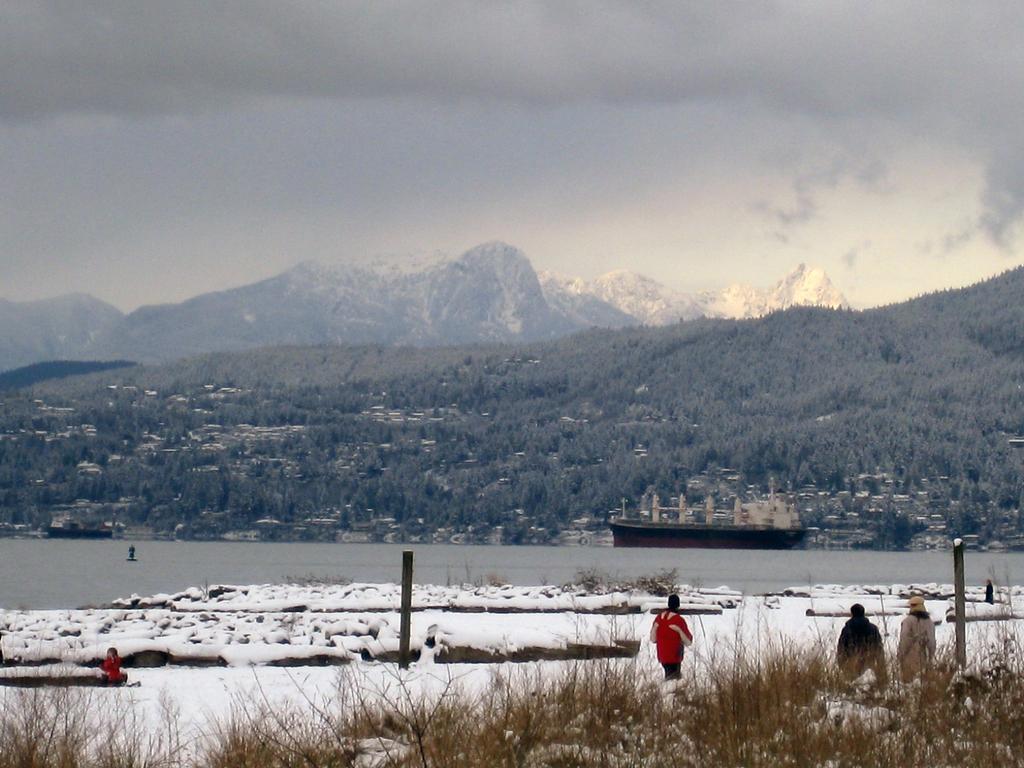Can you describe this image briefly? In this image we can see few people and there is snow on the ground and we can see the lake. There is a ship on the water and we can see the mountains and trees and at the top we can see the cloudy sky. 